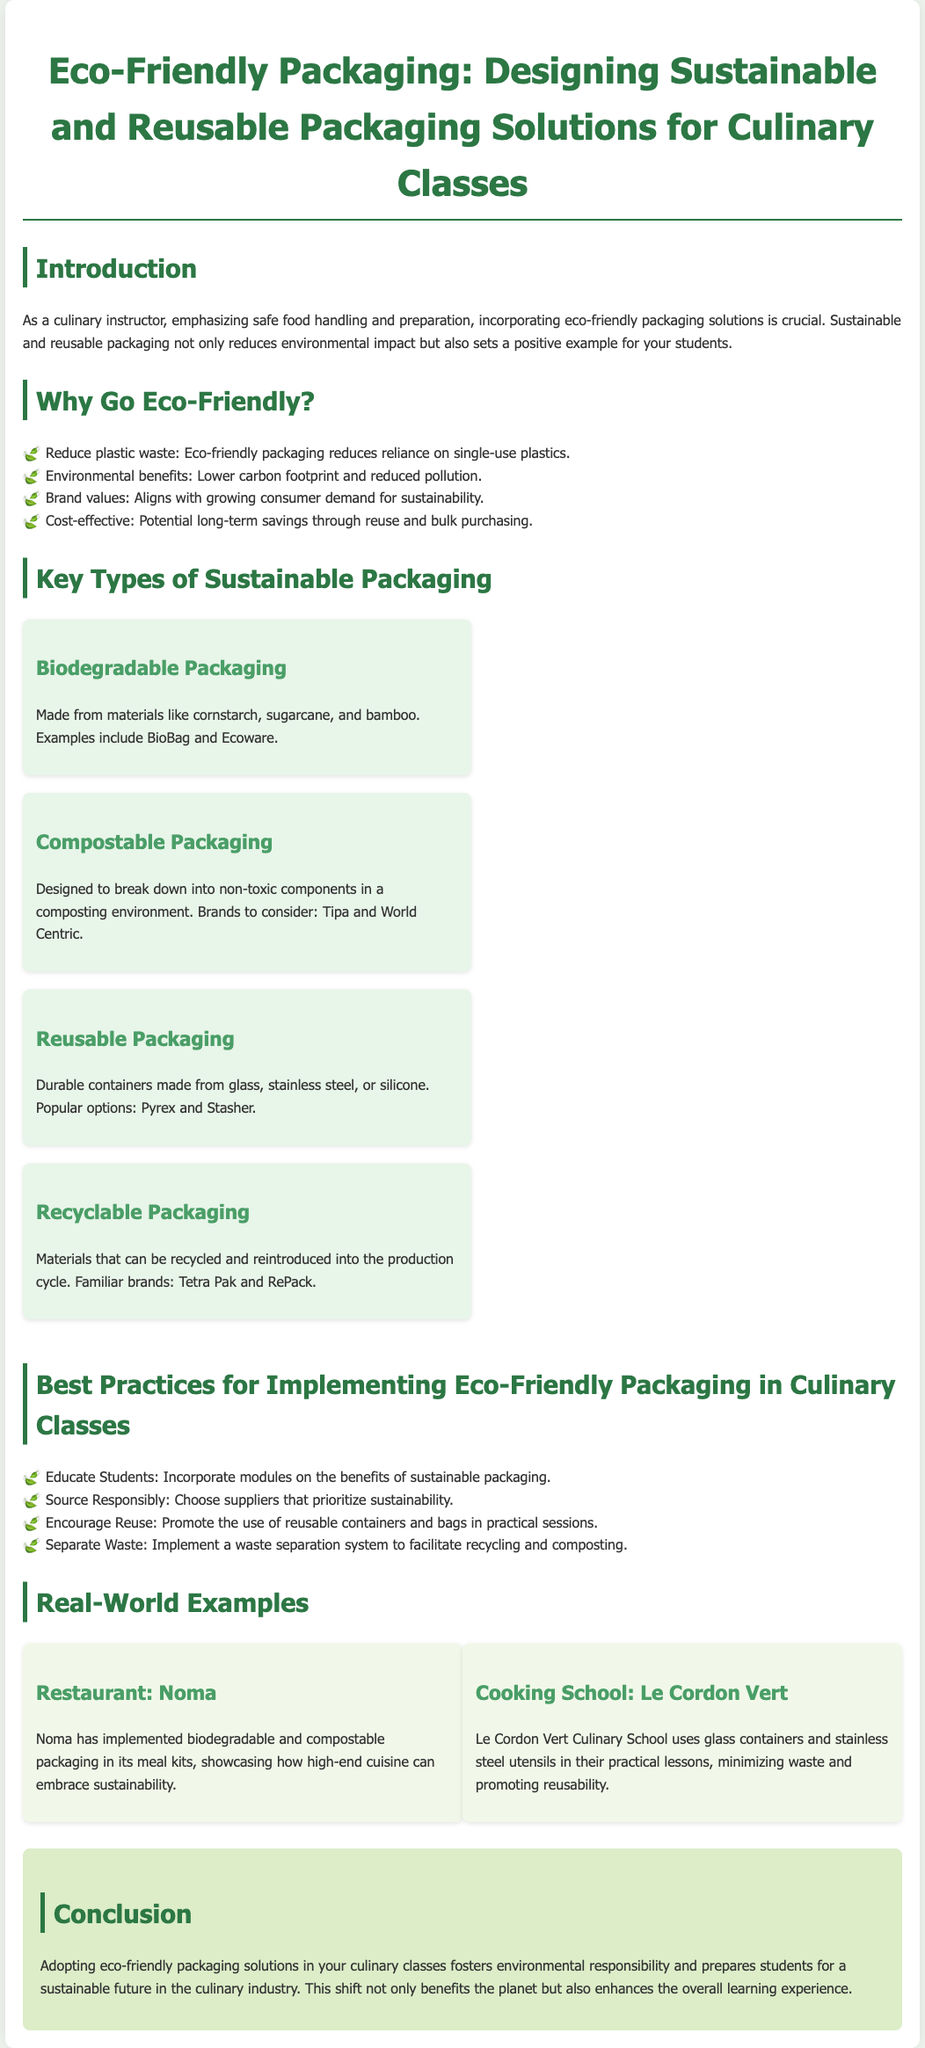What are two examples of biodegradable packaging? The document provides specific brands like BioBag and Ecoware as examples of biodegradable packaging solutions.
Answer: BioBag, Ecoware What type of packaging breaks down into non-toxic components? The document states that compostable packaging is designed to break down into non-toxic components in a composting environment.
Answer: Compostable packaging Which culinary school uses glass containers in its practical lessons? The document mentions Le Cordon Vert Culinary School as using glass containers and stainless steel utensils in its practical lessons.
Answer: Le Cordon Vert What is a benefit of eco-friendly packaging mentioned in the document? The document lists benefits like reducing plastic waste and aligning with consumer demand for sustainability as advantages of eco-friendly packaging.
Answer: Reduce plastic waste Name one best practice for implementing eco-friendly packaging in culinary classes. The document suggests several best practices, one being to educate students about the benefits of sustainable packaging.
Answer: Educate Students How many types of sustainable packaging are listed in the document? The document lists four key types of sustainable packaging: Biodegradable, Compostable, Reusable, and Recyclable.
Answer: Four What is one branding benefit of eco-friendly packaging? One of the benefits mentioned is that eco-friendly packaging aligns with the growing consumer demand for sustainability.
Answer: Brand values What type of containers does Noma use in their meal kits? The document highlights that Noma uses biodegradable and compostable packaging in its meal kits.
Answer: Biodegradable and compostable packaging 